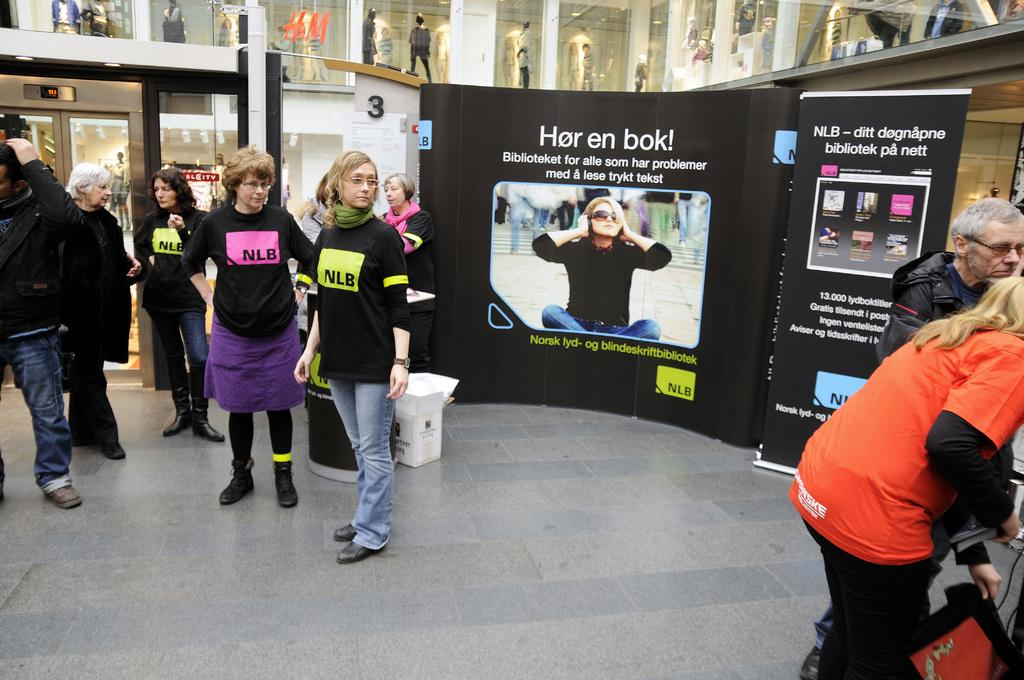How many people are in the image? There are persons standing in the image. What are the people wearing? The persons are wearing clothes. What can be seen in the middle of the image? There is a banner in the middle of the image. What is located at the top of the image? There are display models at the top of the image. What type of oven is visible in the image? There is no oven present in the image. What agreement was reached by the people in the image? The image does not provide information about any agreements reached by the people. 